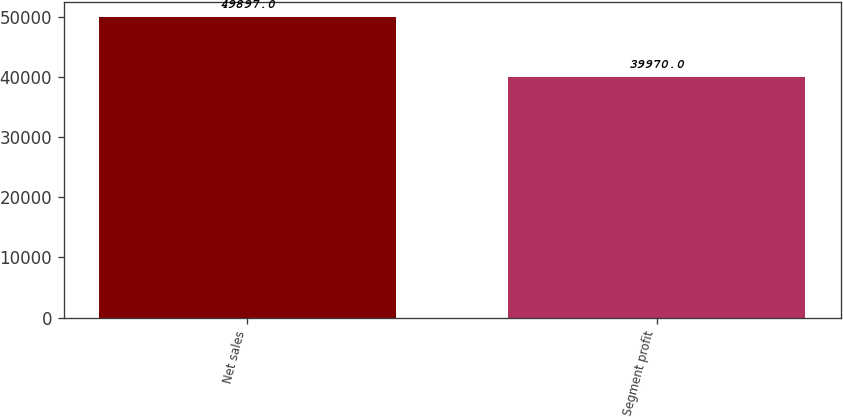Convert chart. <chart><loc_0><loc_0><loc_500><loc_500><bar_chart><fcel>Net sales<fcel>Segment profit<nl><fcel>49897<fcel>39970<nl></chart> 